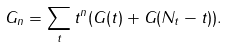<formula> <loc_0><loc_0><loc_500><loc_500>G _ { n } = \sum _ { t } t ^ { n } ( G ( t ) + G ( N _ { t } - t ) ) .</formula> 